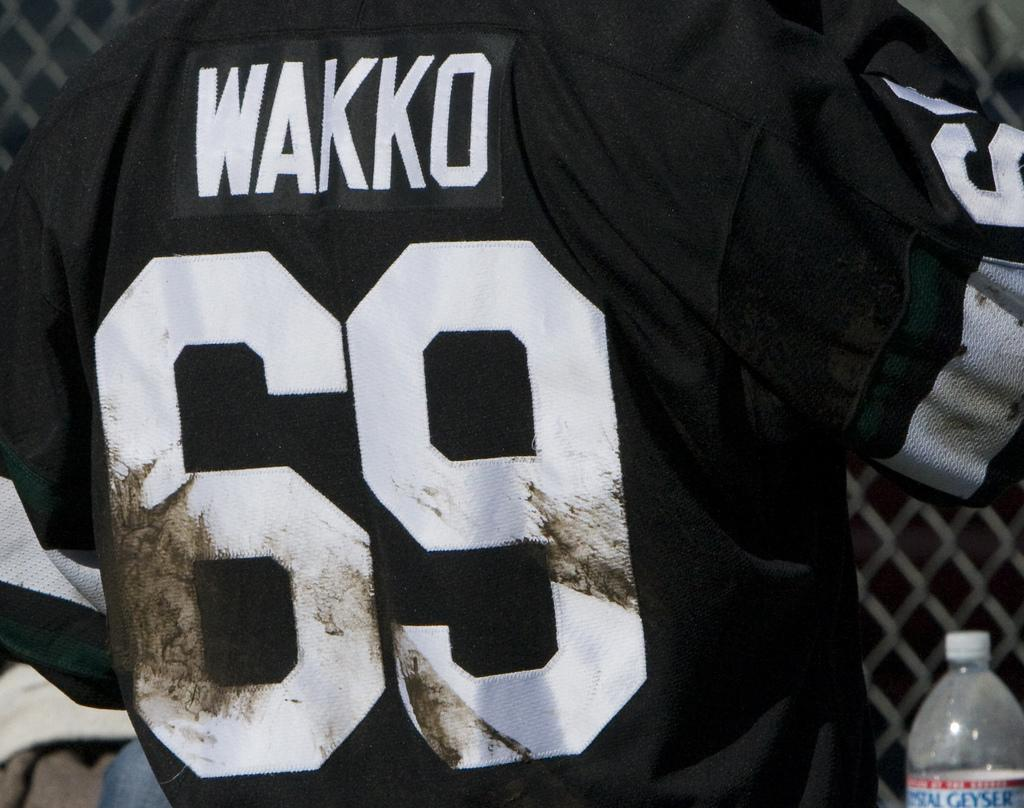<image>
Render a clear and concise summary of the photo. Football player Wakko wears a black jersey with number 69. 